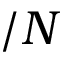<formula> <loc_0><loc_0><loc_500><loc_500>/ N</formula> 